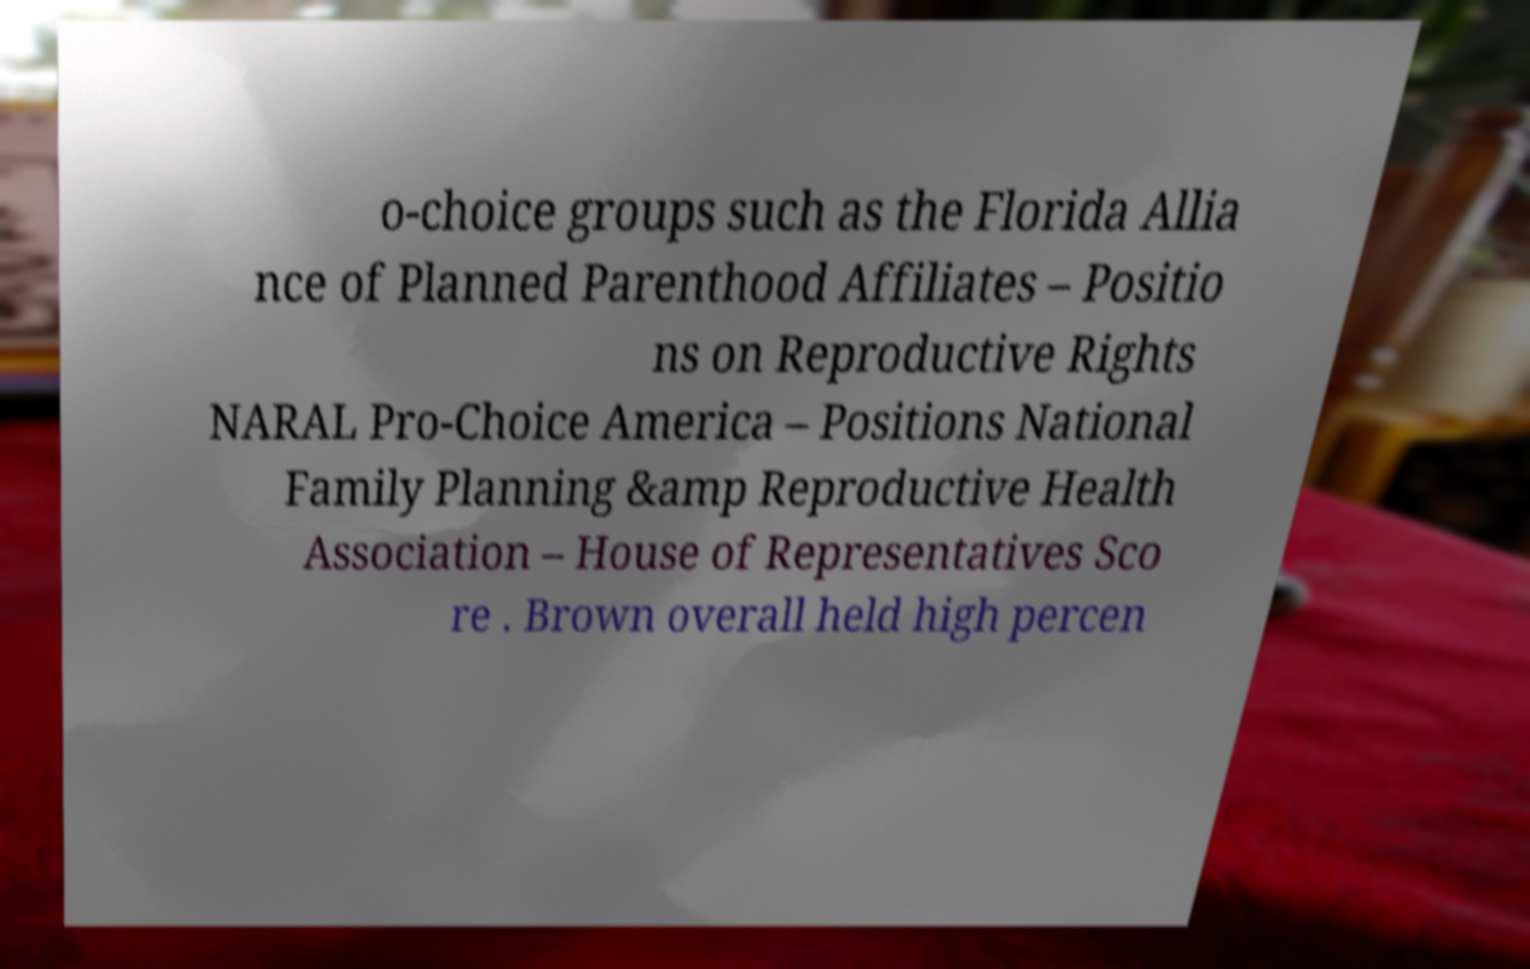Please read and relay the text visible in this image. What does it say? o-choice groups such as the Florida Allia nce of Planned Parenthood Affiliates – Positio ns on Reproductive Rights NARAL Pro-Choice America – Positions National Family Planning &amp Reproductive Health Association – House of Representatives Sco re . Brown overall held high percen 